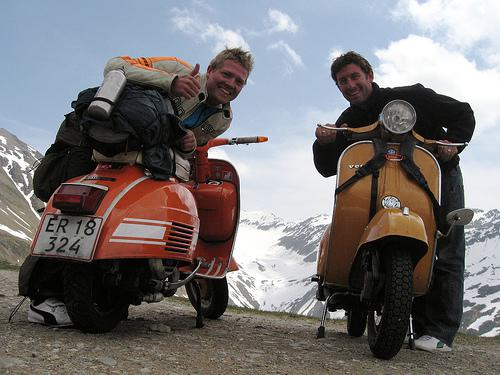What is the setting in which the motorbikes are placed? The motorbikes are placed in a high-altitude setting, likely in a mountainous region, given the snow-capped mountains in the background and the rugged terrain. 